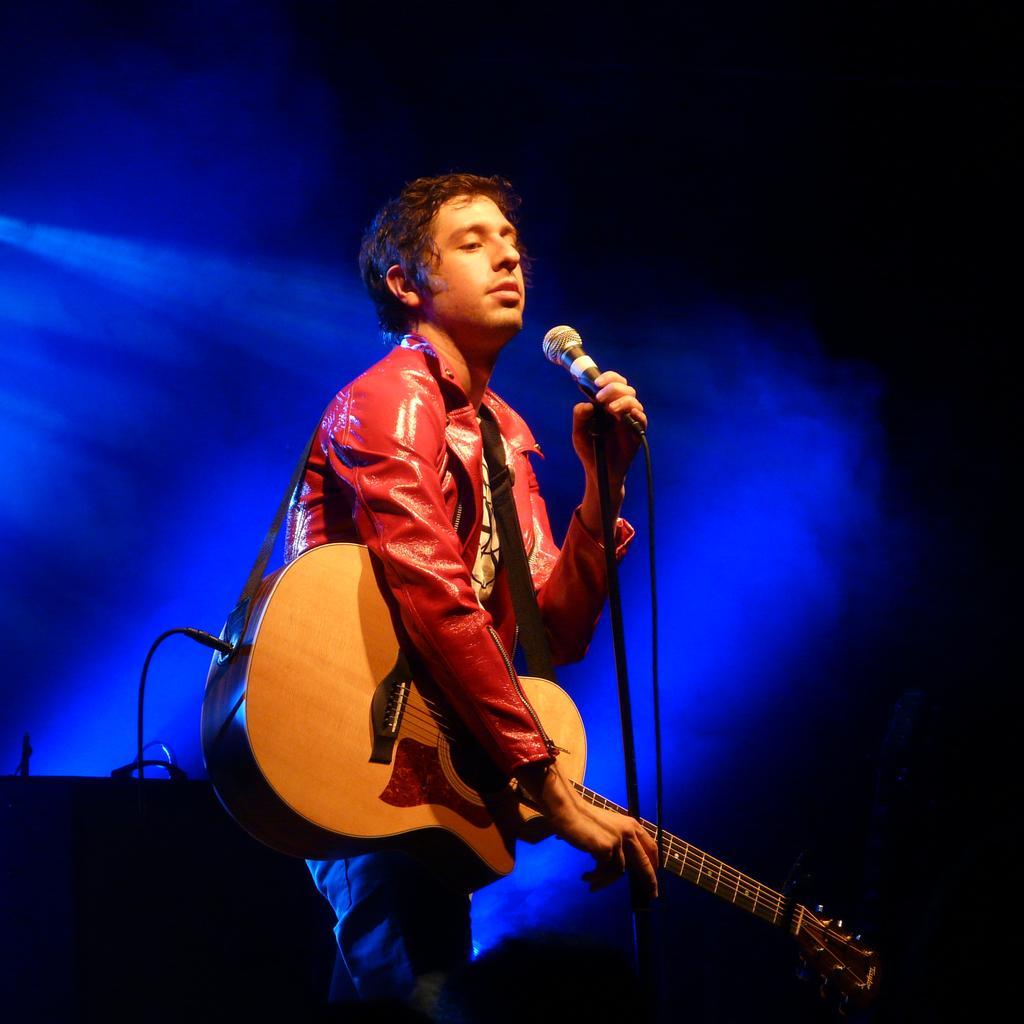Describe this image in one or two sentences. In the image there is a guy playing a guitar in front of a mic. 